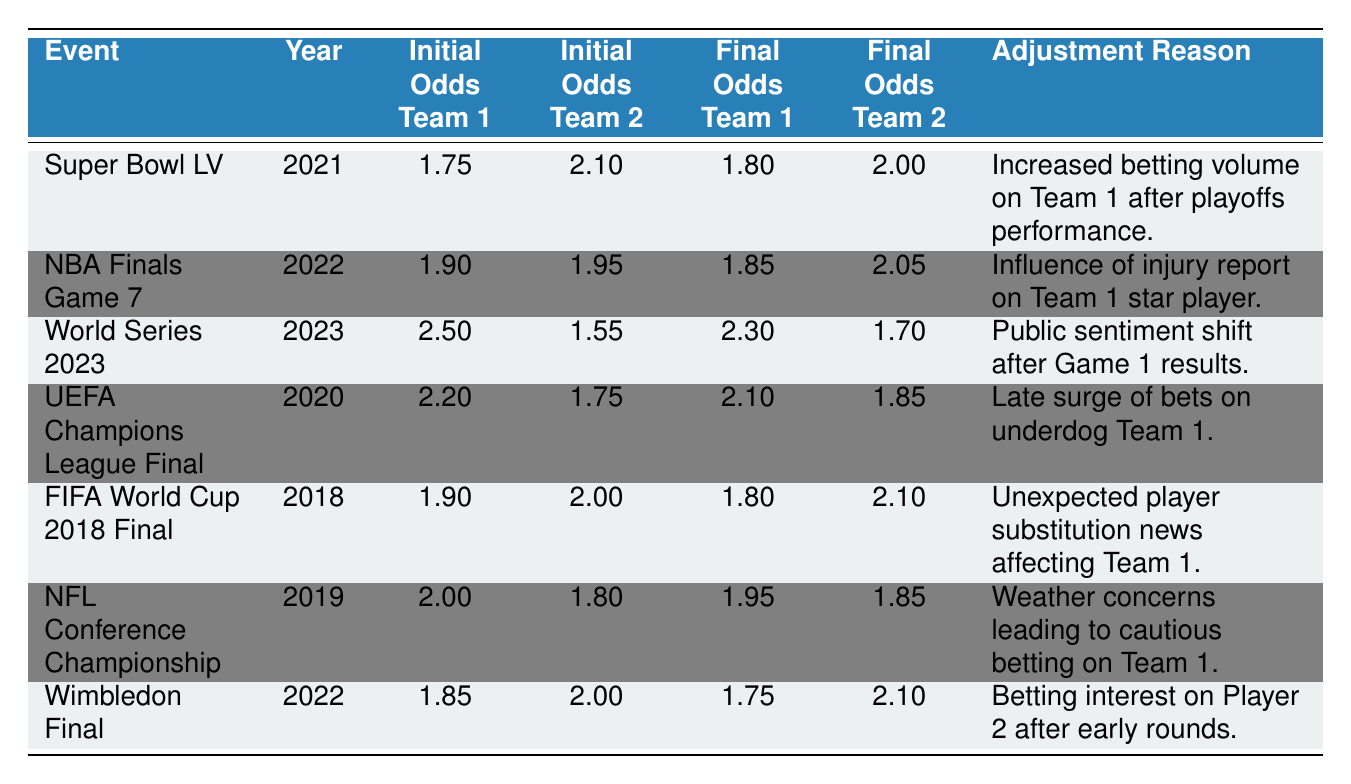What were the initial odds for Team 1 in Super Bowl LV? The initial odds for Team 1 in Super Bowl LV are listed directly in the table. Looking at the row for "Super Bowl LV," we see that the initial odds for Team 1 are 1.75.
Answer: 1.75 What was the final odds adjustment for Team 2 in the NBA Finals Game 7? To find the final odds for Team 2 in the NBA Finals Game 7, I refer to the respective row in the table. The final odds for Team 2 are 2.05.
Answer: 2.05 Was there an increase in the final odds for Team 1 in the FIFA World Cup 2018 Final? In the FIFA World Cup 2018 Final, the initial odds for Team 1 are 1.90 and final odds are 1.80. Since the final odds are lower than the initial odds, it indicates a decrease, not an increase.
Answer: No Which event saw the highest initial odds for Team 1? Reviewing the table for the initial odds of Team 1 across all events, the highest value is 2.50 from the World Series 2023.
Answer: World Series 2023 What is the average final odds for Team 1 across all events? To calculate the average final odds for Team 1, I sum up the final odds for all the events involving Team 1, which are 1.80 (Super Bowl LV) + 1.85 (NBA Finals Game 7) + 2.30 (World Series 2023) + 2.10 (UEFA Champions League Final) + 1.80 (FIFA World Cup 2018 Final) + 1.95 (NFL Conference Championship) + 1.75 (Wimbledon Final) = 13.55. There are 7 data points, so the average is 13.55 / 7 = 1.935.
Answer: 1.935 Did the initial odds for Team 2 decrease in UEFA Champions League Final? In the UEFA Champions League Final, the initial odds for Team 2 are 1.75, and the final odds are 1.85. Since the final odds are higher than the initial odds, it indicates a rise, not a decrease.
Answer: No What is the difference between the final and initial odds for Team 1 in the World Series 2023? The initial odds for Team 1 in the World Series 2023 are 2.50, and the final odds are 2.30. The difference is calculated as 2.50 - 2.30 = 0.20.
Answer: 0.20 How many events had a reason related to injuries or player news? By examining the reasons provided for each event, two events explicitly mention injury or player news: the NBA Finals Game 7 (influence of injury report) and FIFA World Cup 2018 Final (unexpected player substitution). Thus, there are 2 events with such reasons.
Answer: 2 